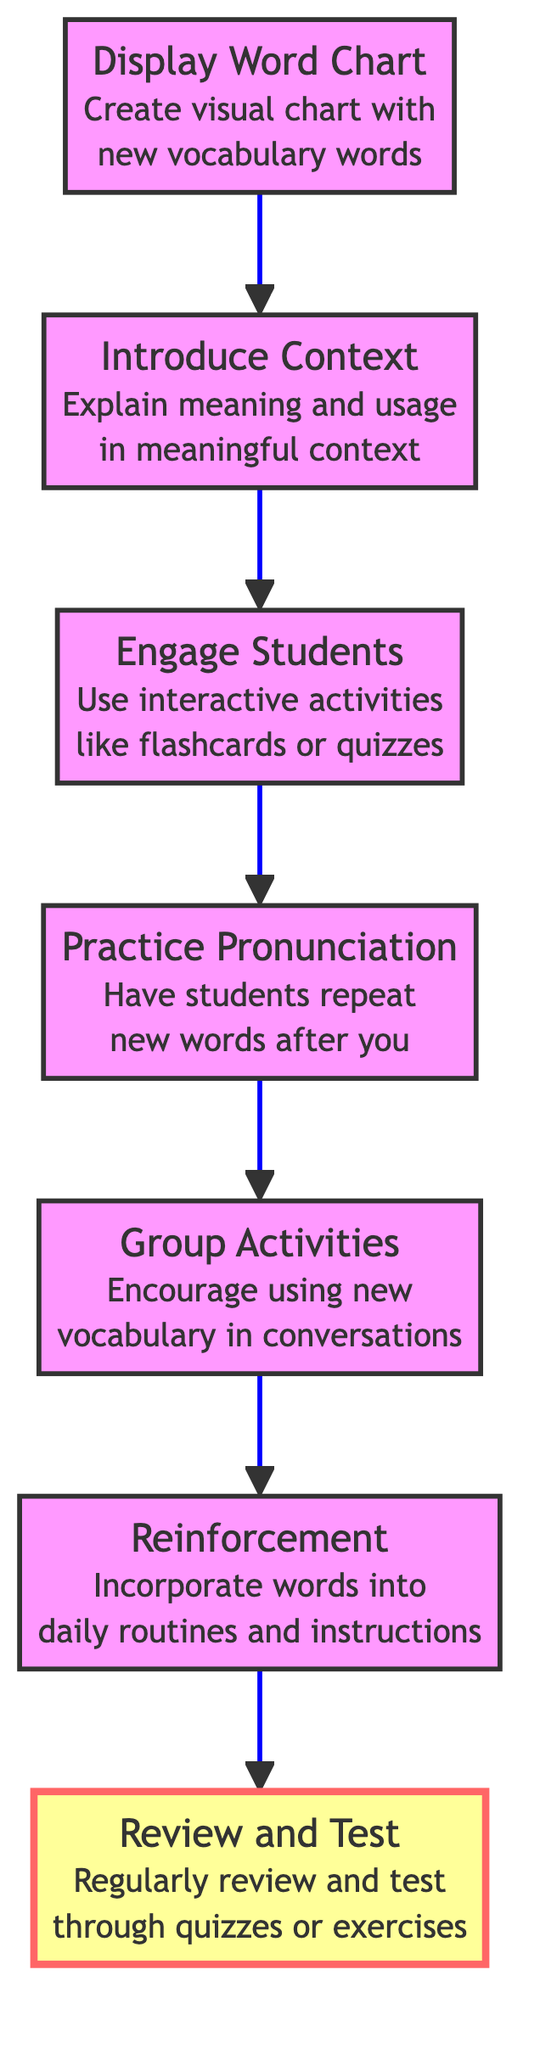What is the first step in the instruction flow? The diagram shows that the first step, or the bottom node, is "Display Word Chart." This is the initial instruction before any other steps occur.
Answer: Display Word Chart How many total steps are present in the flowchart? The flowchart contains a total of seven steps, as reflected by the number of nodes leading up to the final instruction.
Answer: 7 What is the last instruction in the flow? The last instruction at the top of the flowchart is "Review and Test," which indicates it is the final action after all other steps have been completed.
Answer: Review and Test Which two steps come immediately before "Group Activities"? The diagram reveals that the steps that come directly before "Group Activities" are "Practice Pronunciation" and "Engage Students," indicating the order in which students should learn new vocabulary.
Answer: Practice Pronunciation, Engage Students Which step emphasizes interaction with the students? According to the flowchart, the step "Engage Students" emphasizes interactive activities, suggesting that this is where student participation is particularly encouraged.
Answer: Engage Students If a teacher incorporates new vocabulary into daily routines, which step are they following? Incorporating new vocabulary into daily routines corresponds to the "Reinforcement" step, as this is where the vocabulary is used to strengthen learning.
Answer: Reinforcement What instructional activity involves students repeating words? The flowchart clearly indicates that "Practice Pronunciation" is the activity where students are instructed to repeat new words, highlighting the focus on developing correct pronunciation.
Answer: Practice Pronunciation What is the purpose of the "Introduce Context" step? The "Introduce Context" step aims to explain the meaning and usage of new words within meaningful sentences, foundational for understanding vocabulary in context.
Answer: Explain meaning and usage in meaningful context 